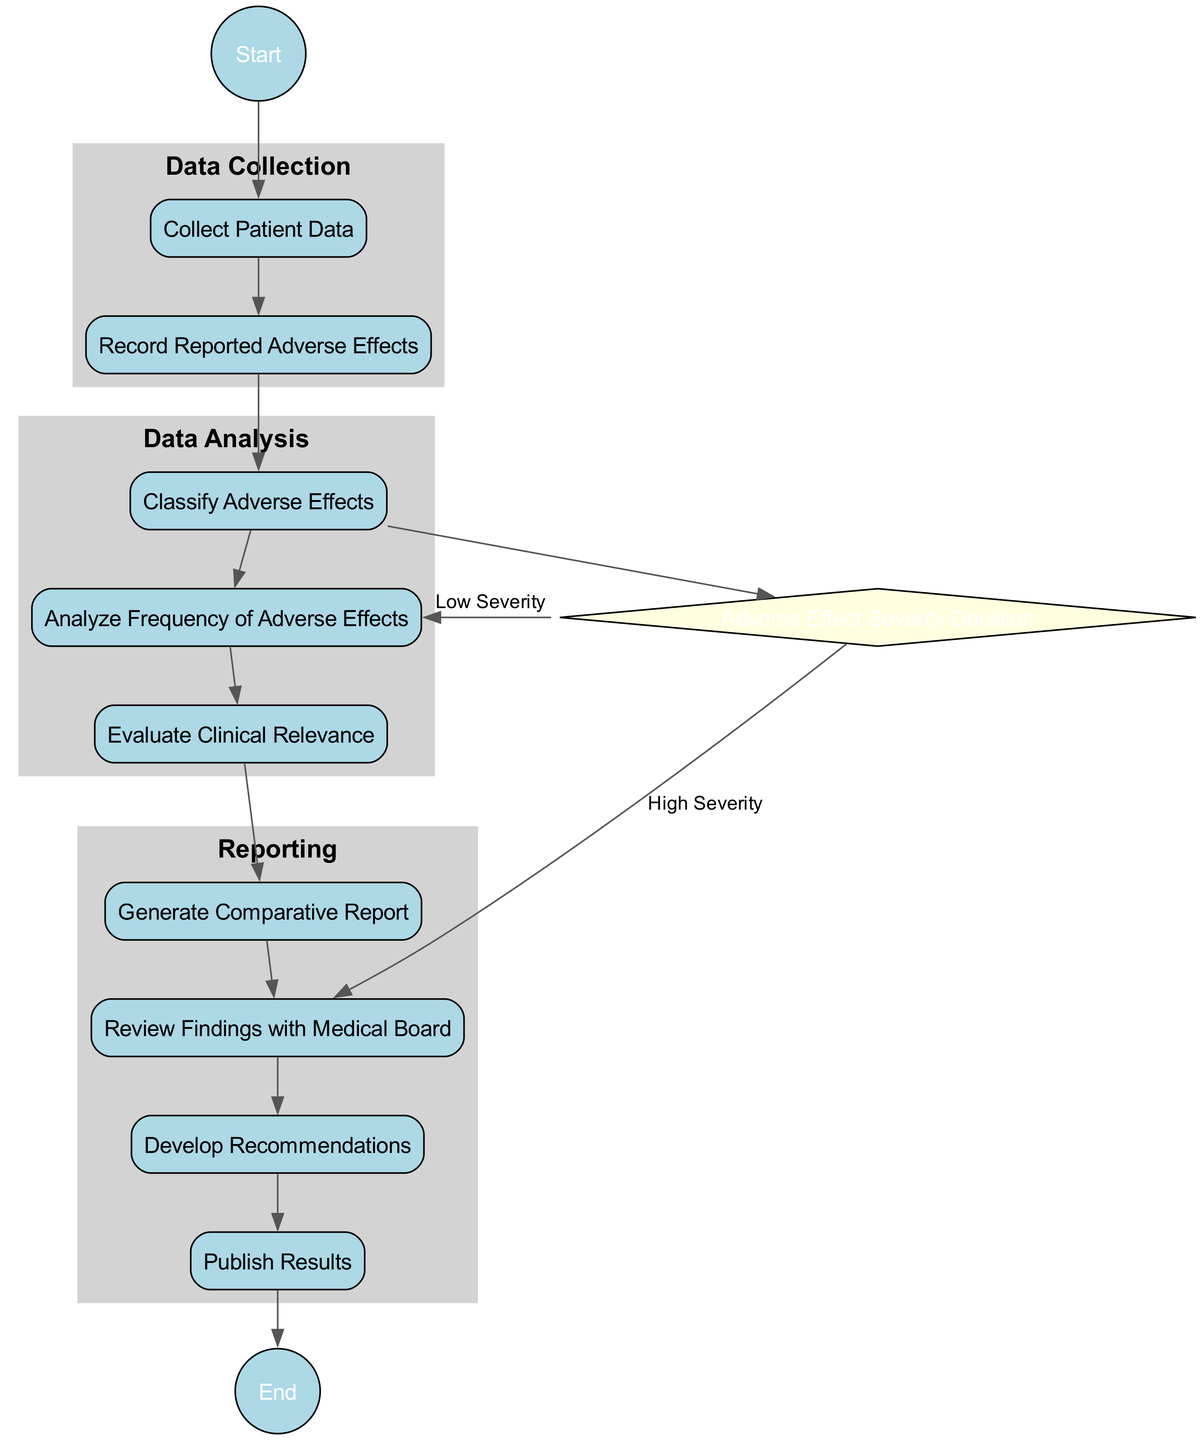What is the first activity in the diagram? The flow starts from the "Start" node, which directly connects to the "Collect Patient Data" activity as the initial step in the process.
Answer: Collect Patient Data How many activities are there in total? The diagram lists 9 distinct activities, including the decision node and three separate phases of data collection, analysis, and reporting.
Answer: 9 What decision comes after the activity "Classify Adverse Effects"? After "Classify Adverse Effects," the flow leads to the decision node called "Adverse Effect Severity Decision," which determines the next steps based on the severity of the adverse effects reported.
Answer: Adverse Effect Severity Decision Which activity is directly linked to "Analyze Frequency of Adverse Effects" if the severity is classified as low? If the severity of the adverse effects is classified as low, the flow continues from "Adverse Effect Severity Decision" directly to "Analyze Frequency of Adverse Effects."
Answer: Analyze Frequency of Adverse Effects What is the last activity in the reporting phase? In the reporting phase, the last activity that is connected before reaching the end of the diagram is "Publish Results," which involves sharing findings with the medical community.
Answer: Publish Results What color is used for the decision node in the diagram? The decision node, identified as "Adverse Effect Severity Decision," is filled in light yellow color according to the attributes set in the diagram structure.
Answer: Light yellow Which swimlane contains the activity "Evaluate Clinical Relevance"? The activity "Evaluate Clinical Relevance" is categorized under the "Data Analysis" swimlane, which encompasses all activities related to the analysis process.
Answer: Data Analysis What happens if the adverse effect severity is classified as high? If classified as high, the flow moves from the decision node "Adverse Effect Severity Decision" to "Review Findings with Medical Board," indicating the need for further attention to these adverse effects.
Answer: Review Findings with Medical Board How many swimlanes does the diagram feature? The diagram organizes the activities into three distinct swimlanes that categorize the processes of data collection, data analysis, and reporting.
Answer: 3 